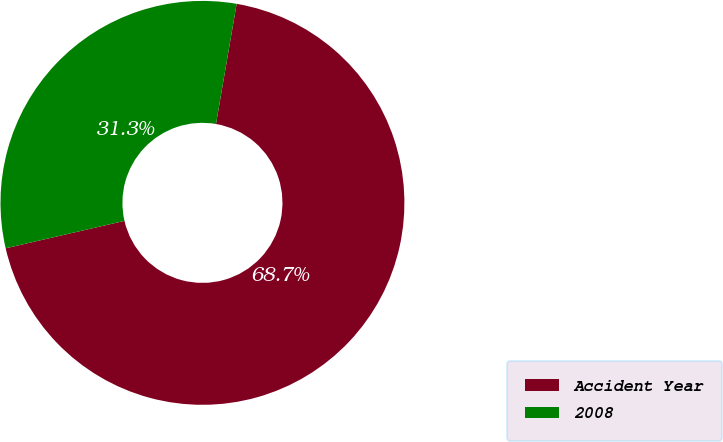<chart> <loc_0><loc_0><loc_500><loc_500><pie_chart><fcel>Accident Year<fcel>2008<nl><fcel>68.68%<fcel>31.32%<nl></chart> 